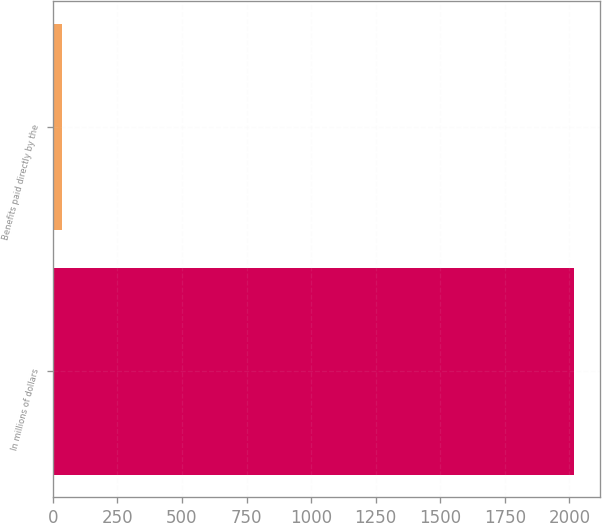Convert chart to OTSL. <chart><loc_0><loc_0><loc_500><loc_500><bar_chart><fcel>In millions of dollars<fcel>Benefits paid directly by the<nl><fcel>2017<fcel>36<nl></chart> 